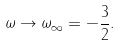Convert formula to latex. <formula><loc_0><loc_0><loc_500><loc_500>\omega \rightarrow \omega _ { \infty } = - \frac { 3 } { 2 } .</formula> 